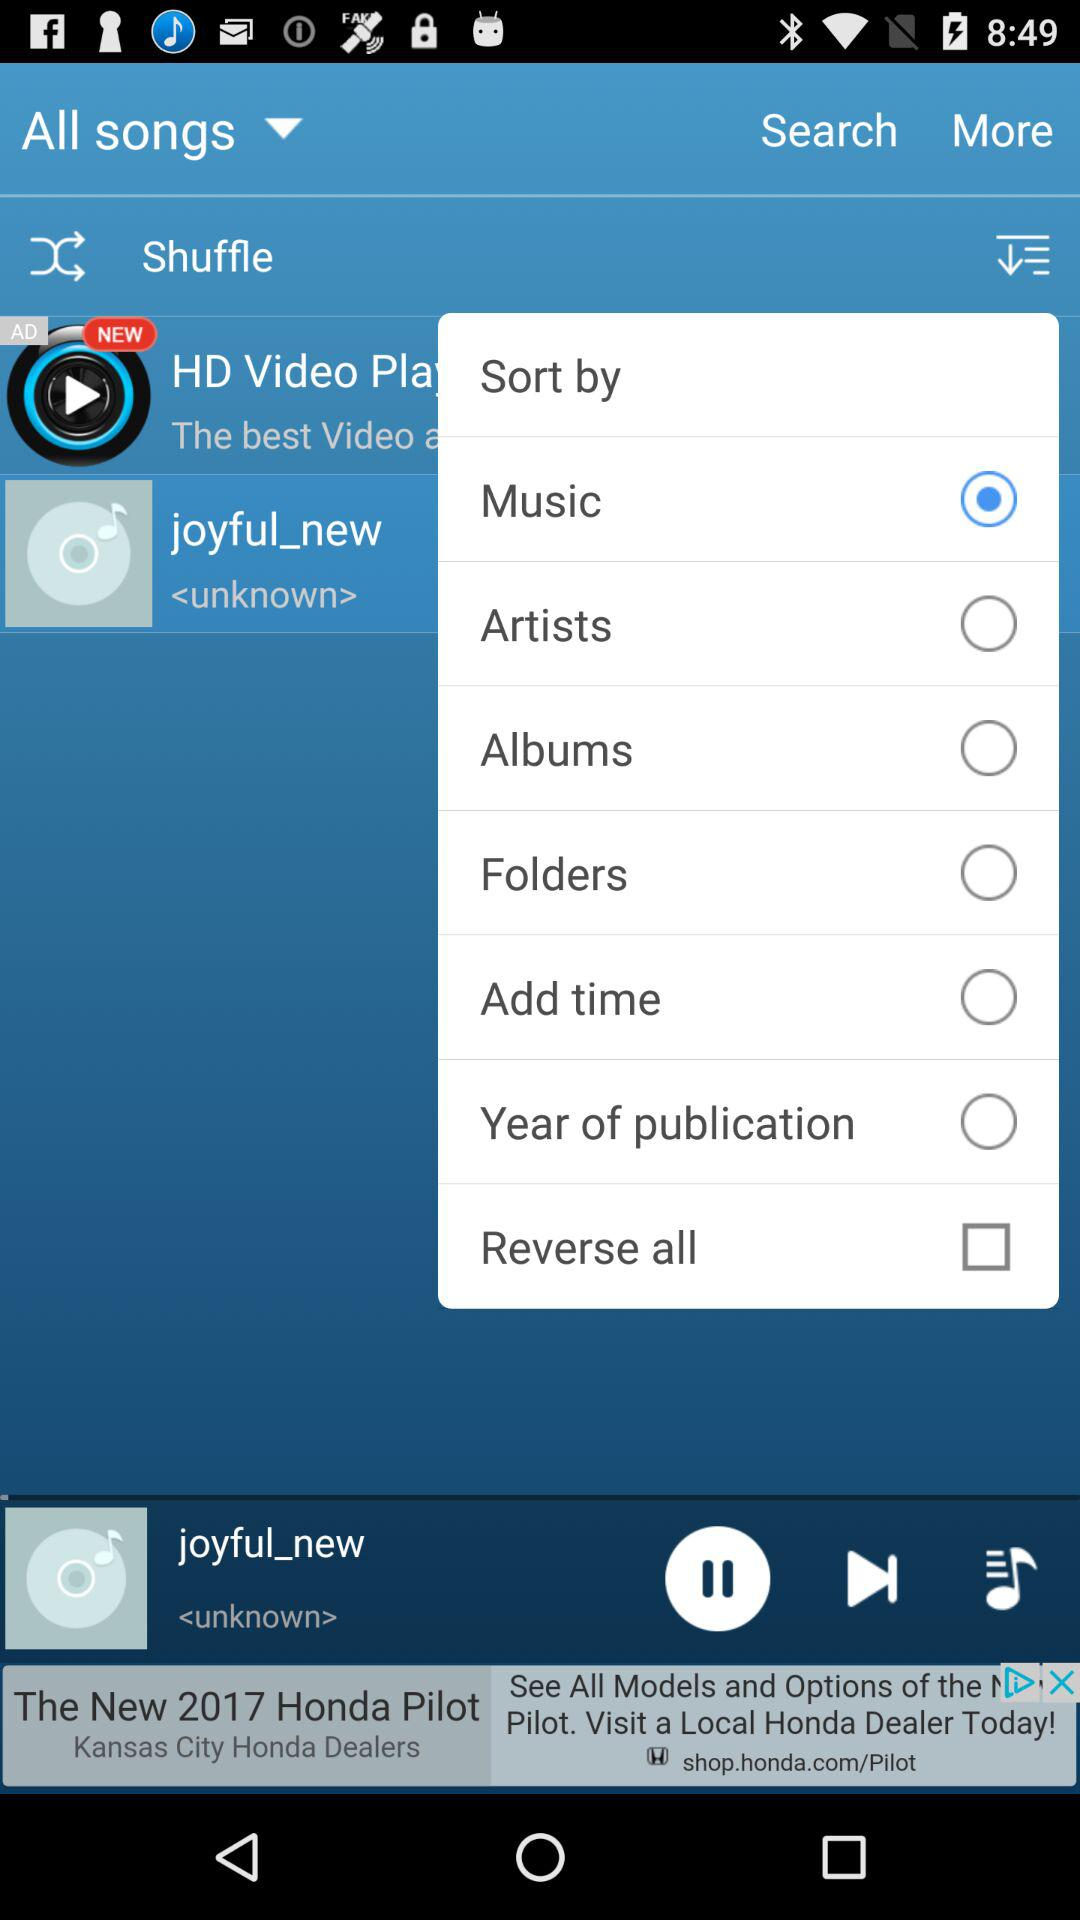What is the duration of "joyful_new"?
When the provided information is insufficient, respond with <no answer>. <no answer> 